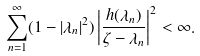Convert formula to latex. <formula><loc_0><loc_0><loc_500><loc_500>\sum _ { n = 1 } ^ { \infty } ( 1 - | \lambda _ { n } | ^ { 2 } ) \left | \frac { h ( \lambda _ { n } ) } { \zeta - \lambda _ { n } } \right | ^ { 2 } < \infty .</formula> 